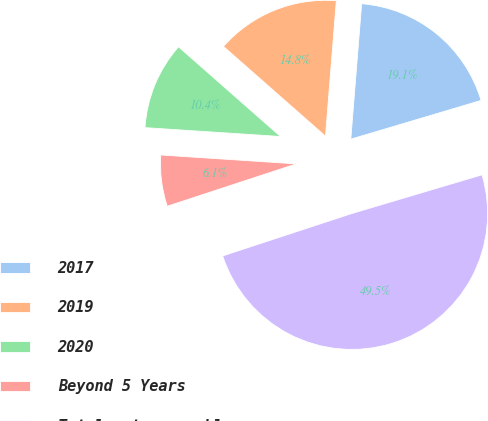Convert chart to OTSL. <chart><loc_0><loc_0><loc_500><loc_500><pie_chart><fcel>2017<fcel>2019<fcel>2020<fcel>Beyond 5 Years<fcel>Total notes payable<nl><fcel>19.13%<fcel>14.79%<fcel>10.44%<fcel>6.09%<fcel>49.55%<nl></chart> 